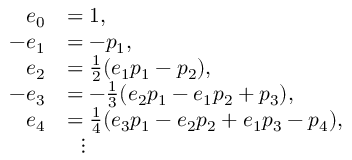<formula> <loc_0><loc_0><loc_500><loc_500>{ \begin{array} { r l } { e _ { 0 } } & { = 1 , } \\ { - e _ { 1 } } & { = - p _ { 1 } , } \\ { e _ { 2 } } & { = { \frac { 1 } { 2 } } ( e _ { 1 } p _ { 1 } - p _ { 2 } ) , } \\ { - e _ { 3 } } & { = - { \frac { 1 } { 3 } } ( e _ { 2 } p _ { 1 } - e _ { 1 } p _ { 2 } + p _ { 3 } ) , } \\ { e _ { 4 } } & { = { \frac { 1 } { 4 } } ( e _ { 3 } p _ { 1 } - e _ { 2 } p _ { 2 } + e _ { 1 } p _ { 3 } - p _ { 4 } ) , } \\ & { \quad v d o t s } \end{array} }</formula> 